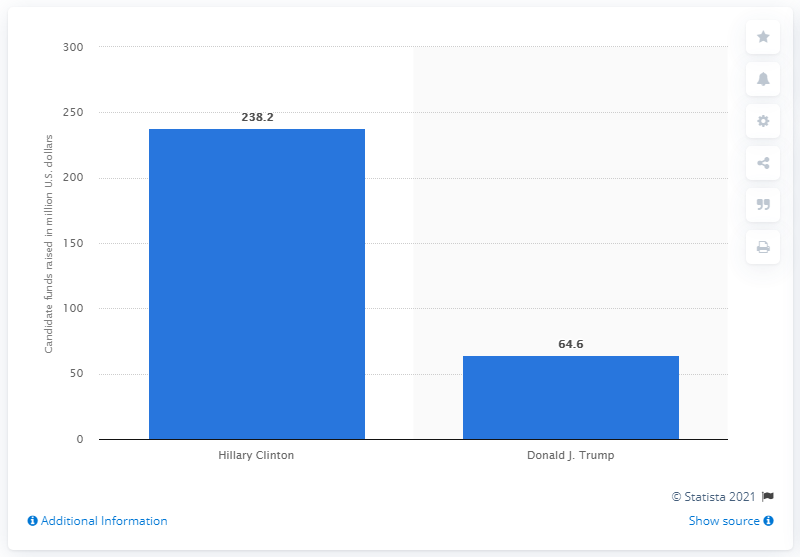Mention a couple of crucial points in this snapshot. Hillary Clinton raised a significant amount of money for her campaign, with a total of 238.2 million dollars. Hillary Clinton raised the most money for her presidential campaign among all candidates. 